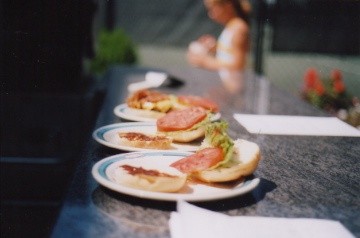Describe the objects in this image and their specific colors. I can see people in black, tan, brown, and maroon tones, sandwich in black, tan, lightgray, and olive tones, sandwich in black, tan, and red tones, sandwich in black, tan, and lightgray tones, and sandwich in black, tan, red, and salmon tones in this image. 